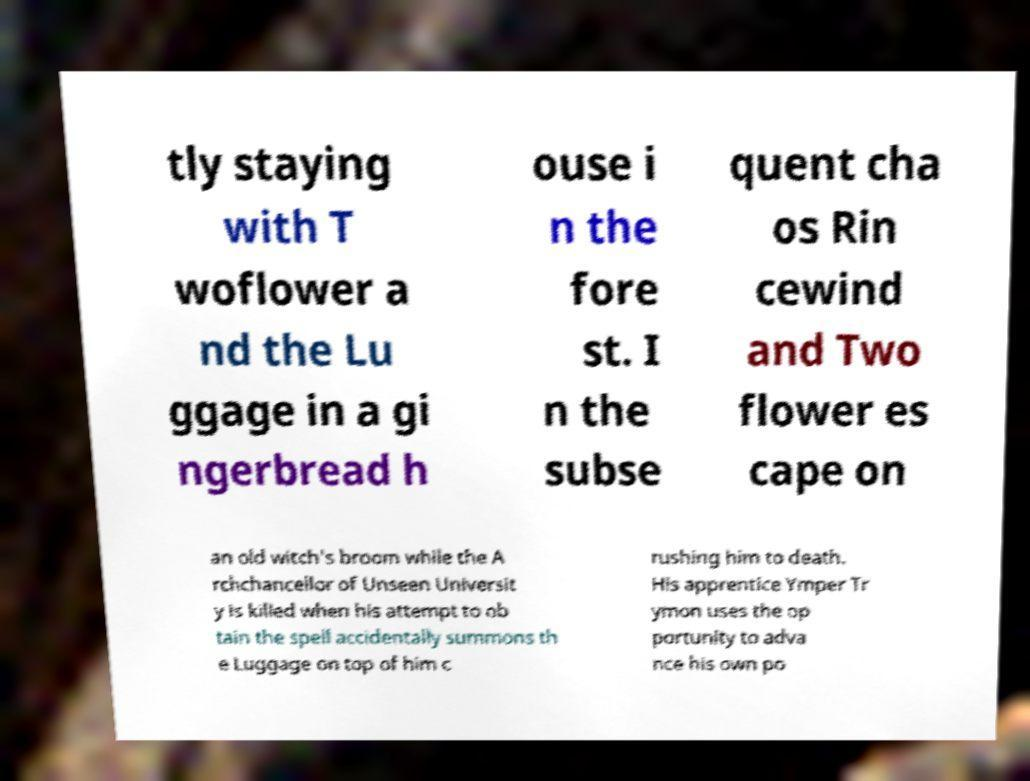For documentation purposes, I need the text within this image transcribed. Could you provide that? tly staying with T woflower a nd the Lu ggage in a gi ngerbread h ouse i n the fore st. I n the subse quent cha os Rin cewind and Two flower es cape on an old witch's broom while the A rchchancellor of Unseen Universit y is killed when his attempt to ob tain the spell accidentally summons th e Luggage on top of him c rushing him to death. His apprentice Ymper Tr ymon uses the op portunity to adva nce his own po 